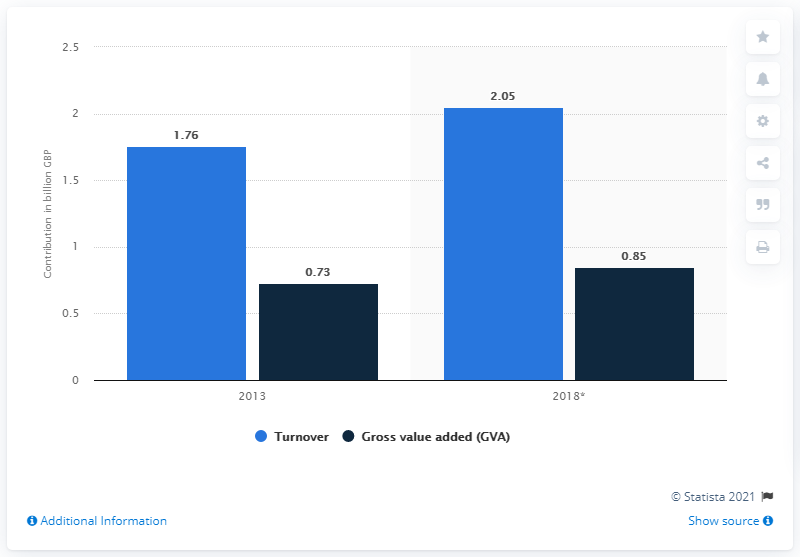Specify some key components in this picture. There are two bars that have a value below 1. The value of the leftmost bar is 1.76. 